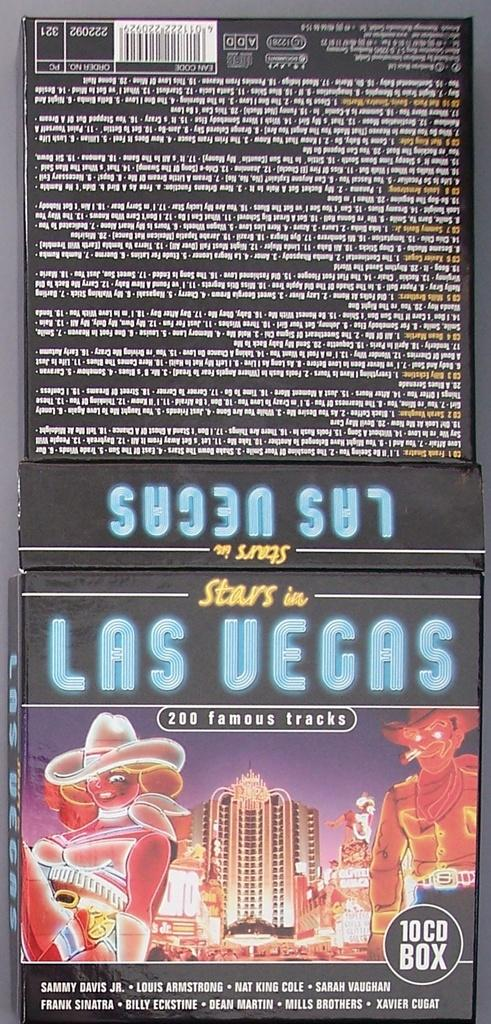<image>
Relay a brief, clear account of the picture shown. The 10 CD Box of Stars in Las Vegas includes Sammy Davis Jr., Louis Armstrong, Nat King Cole, and Sarah Vaughan. 